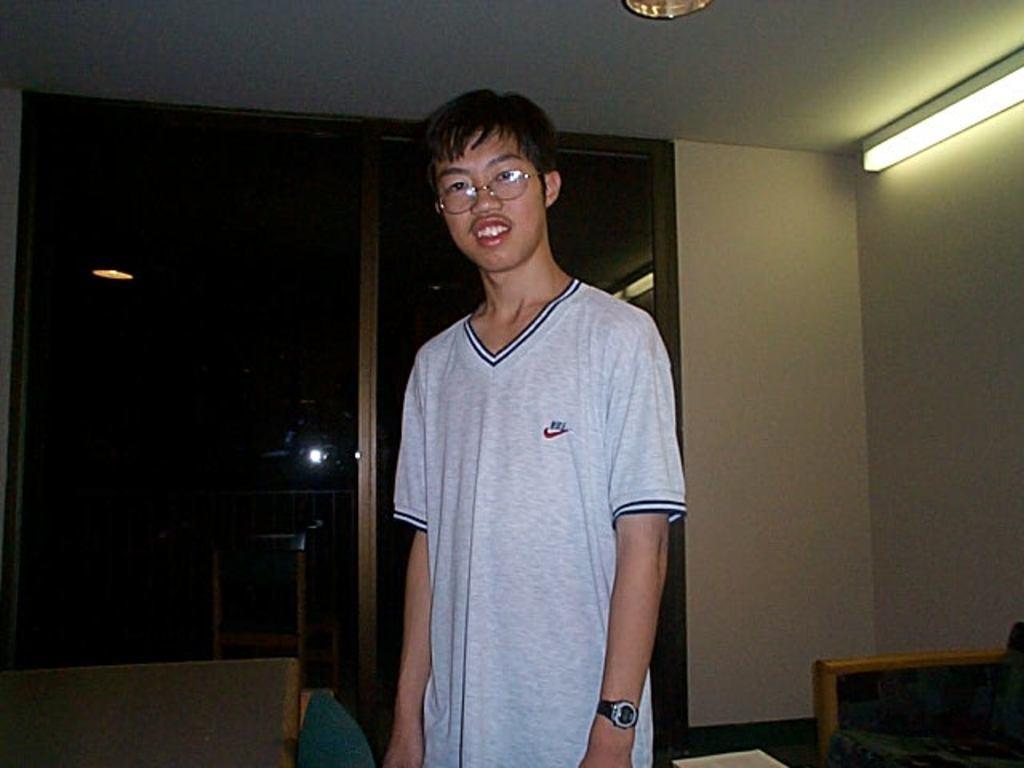Describe this image in one or two sentences. In the foreground of this image, there is a men in ash T shirt and on right there is a couch, a wall and the light. On left there is a couch, a glass door and a light in the background. On top, there is a ceiling. 